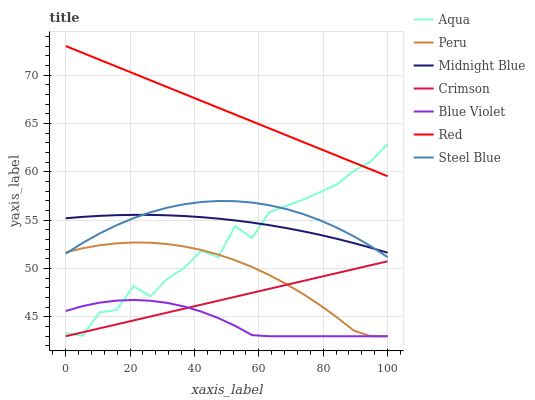Does Blue Violet have the minimum area under the curve?
Answer yes or no. Yes. Does Red have the maximum area under the curve?
Answer yes or no. Yes. Does Aqua have the minimum area under the curve?
Answer yes or no. No. Does Aqua have the maximum area under the curve?
Answer yes or no. No. Is Crimson the smoothest?
Answer yes or no. Yes. Is Aqua the roughest?
Answer yes or no. Yes. Is Steel Blue the smoothest?
Answer yes or no. No. Is Steel Blue the roughest?
Answer yes or no. No. Does Blue Violet have the lowest value?
Answer yes or no. Yes. Does Aqua have the lowest value?
Answer yes or no. No. Does Red have the highest value?
Answer yes or no. Yes. Does Aqua have the highest value?
Answer yes or no. No. Is Peru less than Midnight Blue?
Answer yes or no. Yes. Is Midnight Blue greater than Peru?
Answer yes or no. Yes. Does Blue Violet intersect Peru?
Answer yes or no. Yes. Is Blue Violet less than Peru?
Answer yes or no. No. Is Blue Violet greater than Peru?
Answer yes or no. No. Does Peru intersect Midnight Blue?
Answer yes or no. No. 